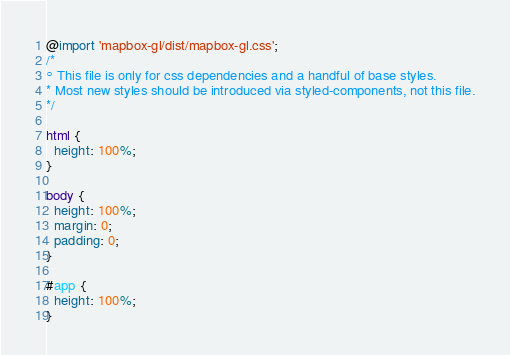<code> <loc_0><loc_0><loc_500><loc_500><_CSS_>@import 'mapbox-gl/dist/mapbox-gl.css';
/*
° This file is only for css dependencies and a handful of base styles.
* Most new styles should be introduced via styled-components, not this file.
*/

html {
  height: 100%;
}

body {
  height: 100%;
  margin: 0;
  padding: 0;
}

#app {
  height: 100%;
}
</code> 